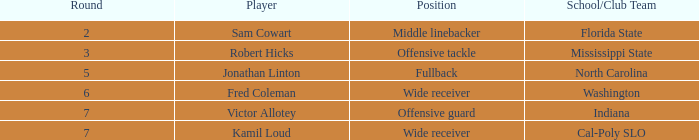Which participant has a round under 5 and belongs to a school/club team in florida state? Sam Cowart. 